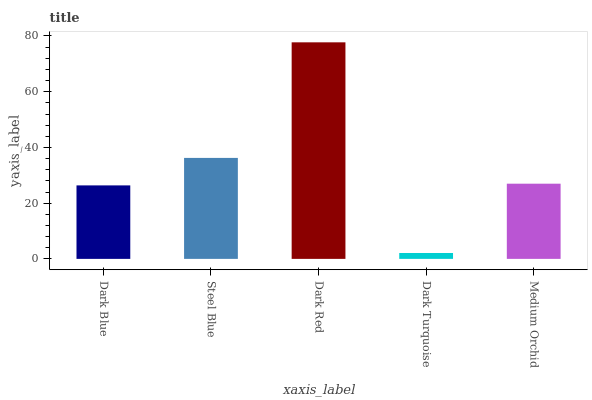Is Dark Turquoise the minimum?
Answer yes or no. Yes. Is Dark Red the maximum?
Answer yes or no. Yes. Is Steel Blue the minimum?
Answer yes or no. No. Is Steel Blue the maximum?
Answer yes or no. No. Is Steel Blue greater than Dark Blue?
Answer yes or no. Yes. Is Dark Blue less than Steel Blue?
Answer yes or no. Yes. Is Dark Blue greater than Steel Blue?
Answer yes or no. No. Is Steel Blue less than Dark Blue?
Answer yes or no. No. Is Medium Orchid the high median?
Answer yes or no. Yes. Is Medium Orchid the low median?
Answer yes or no. Yes. Is Dark Blue the high median?
Answer yes or no. No. Is Dark Red the low median?
Answer yes or no. No. 